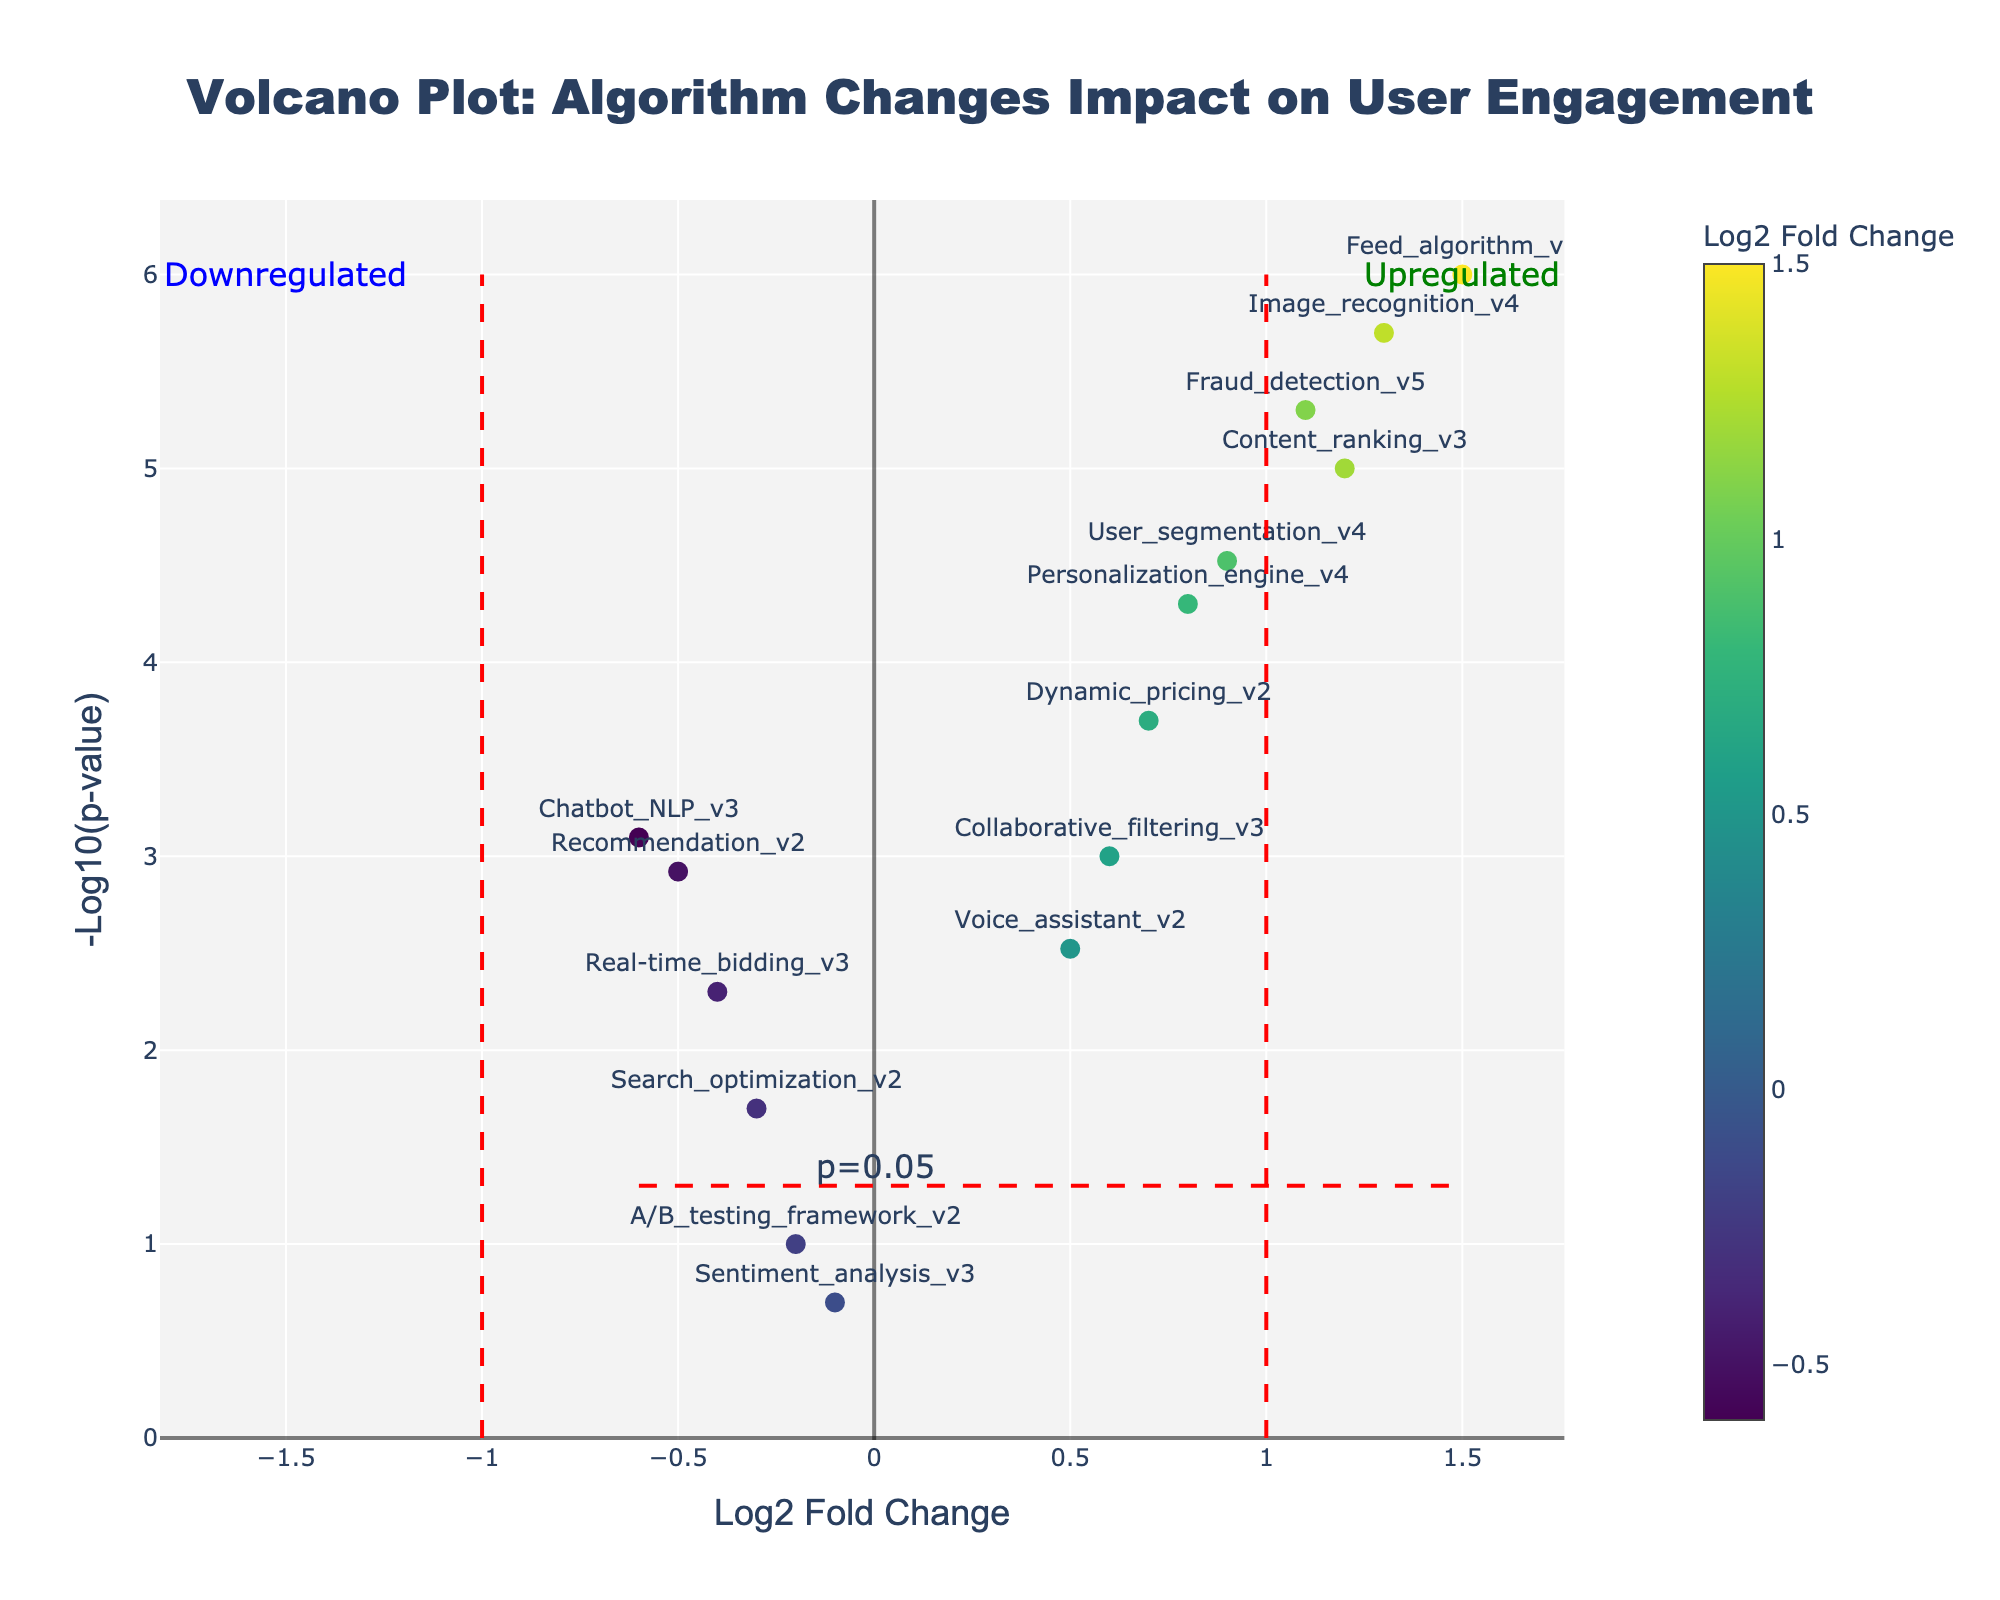What's the title of the plot? The title of the plot can be found at the top of the figure, describing the overall content and purpose.
Answer: Volcano Plot: Algorithm Changes Impact on User Engagement What do the x and y axes represent? The x-axis represents the Log2 Fold Change of user engagement metrics across different algorithm iterations, and the y-axis represents the -Log10 of the p-value, which indicates the statistical significance of the changes.
Answer: Log2 Fold Change and -Log10(p-value) How many data points represent "upregulated" algorithms? Upregulated algorithms have log2 fold changes greater than 1. Count the points above the horizontal line at y = -log10(0.05) and to the right of the vertical line at x = 1.
Answer: 4 Which algorithm iteration shows the most significant increase in user engagement? The most significant increase is indicated by the highest value on the y-axis for data points with a positive log2 fold change. Identify the highest data point on the positive side.
Answer: Feed_algorithm_v5 Which algorithm shows a significant negative impact on user engagement? Look for the algorithms with log2 fold changes less than 0 and y-values above -log10(0.05). Find the one with the smallest log2 fold change and the highest -log10(p-value).
Answer: Chatbot_NLP_v3 How many algorithms show statistically significant changes in user engagement? Statistically significant changes are represented by data points above the horizontal line at y = -log10(0.05). Count all such data points.
Answer: 11 Between "Dynamic_pricing_v2" and "Voice_assistant_v2", which algorithm has a higher impact on user engagement? Compare the log2 fold changes of both algorithms. The one with the higher log2 fold change has a higher impact.
Answer: Dynamic_pricing_v2 Is there any algorithm iteration that shows insignificant changes in user engagement? Insignificant changes are represented by data points below the horizontal line at y = -log10(0.05). Check for any such data points.
Answer: A/B_testing_framework_v2 and Sentiment_analysis_v3 Which color scale is used in the plot to represent the Log2 Fold Change values? Observe the color bar next to the scatter plot, which shows the gradient or scale of colors representing different log2 fold change values.
Answer: Viridis 